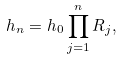Convert formula to latex. <formula><loc_0><loc_0><loc_500><loc_500>h _ { n } = h _ { 0 } \prod _ { j = 1 } ^ { n } R _ { j } ,</formula> 